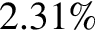Convert formula to latex. <formula><loc_0><loc_0><loc_500><loc_500>2 . 3 1 \%</formula> 